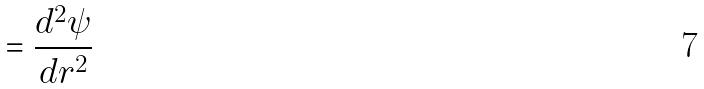Convert formula to latex. <formula><loc_0><loc_0><loc_500><loc_500>= \frac { d ^ { 2 } \psi } { d r ^ { 2 } }</formula> 